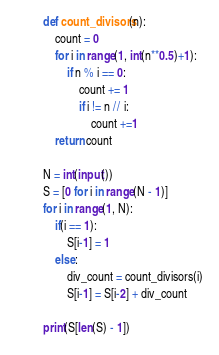Convert code to text. <code><loc_0><loc_0><loc_500><loc_500><_Python_>def count_divisors(n):
    count = 0
    for i in range(1, int(n**0.5)+1):
        if n % i == 0:
            count += 1
            if i != n // i:
                count +=1
    return count
 
N = int(input())
S = [0 for i in range(N - 1)]
for i in range(1, N):
    if(i == 1):
        S[i-1] = 1
    else:
        div_count = count_divisors(i)
        S[i-1] = S[i-2] + div_count

print(S[len(S) - 1])
</code> 